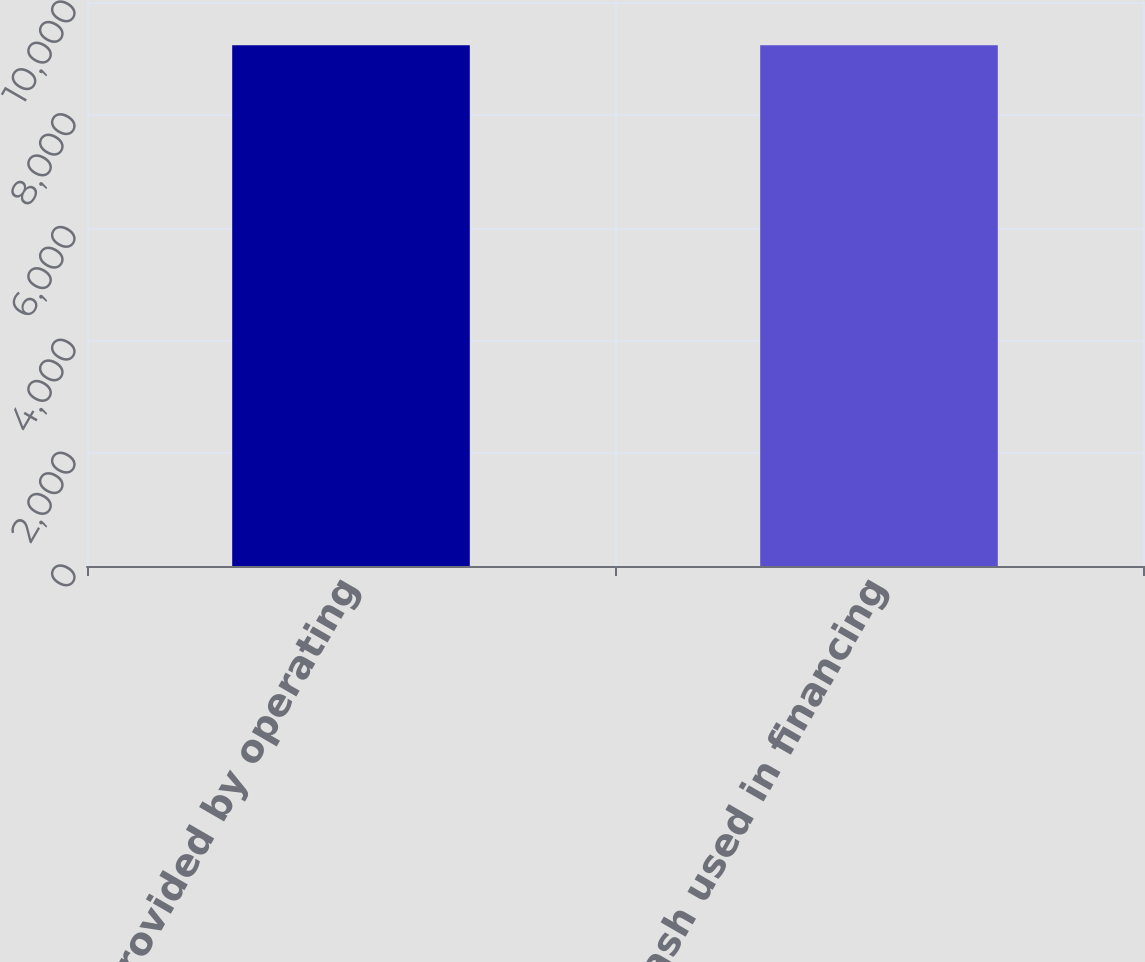Convert chart. <chart><loc_0><loc_0><loc_500><loc_500><bar_chart><fcel>Net cash provided by operating<fcel>Net cash used in financing<nl><fcel>9232<fcel>9232.1<nl></chart> 